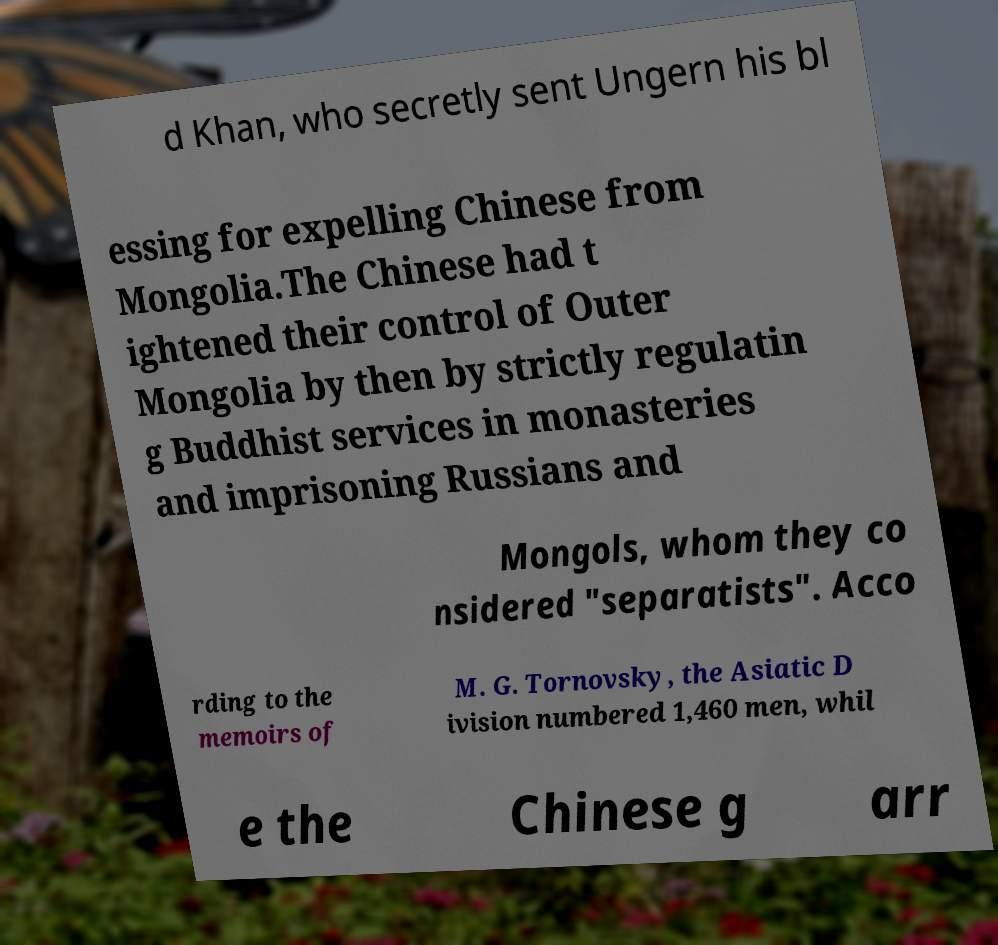I need the written content from this picture converted into text. Can you do that? d Khan, who secretly sent Ungern his bl essing for expelling Chinese from Mongolia.The Chinese had t ightened their control of Outer Mongolia by then by strictly regulatin g Buddhist services in monasteries and imprisoning Russians and Mongols, whom they co nsidered "separatists". Acco rding to the memoirs of M. G. Tornovsky, the Asiatic D ivision numbered 1,460 men, whil e the Chinese g arr 